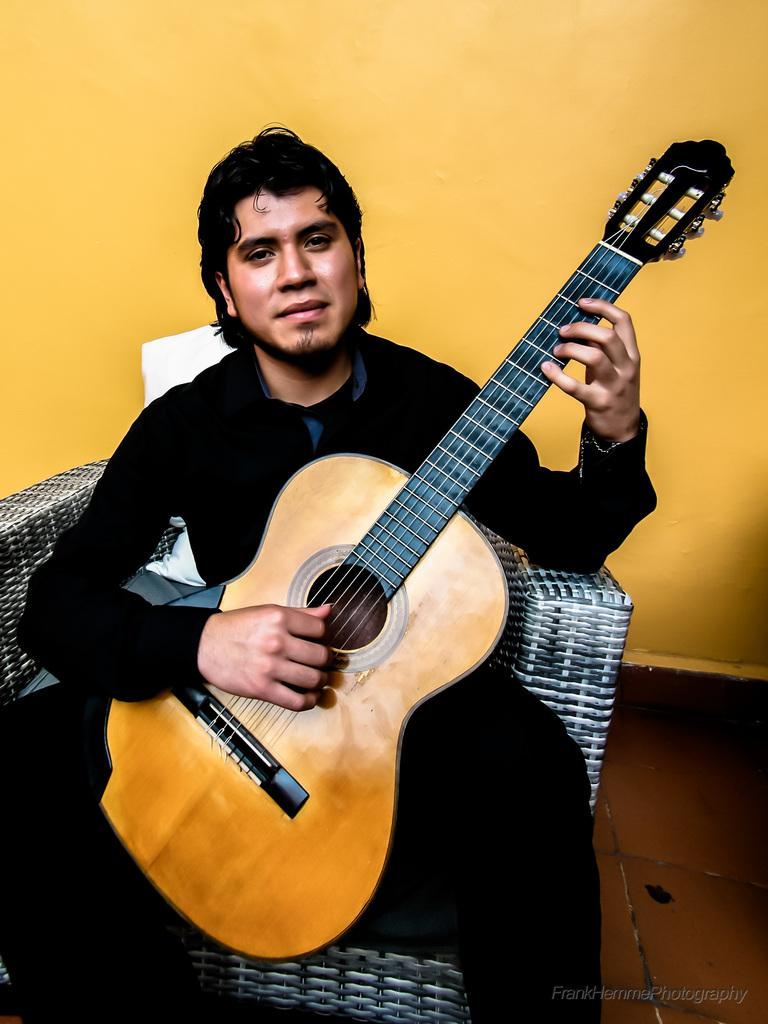What is the main subject of the image? The main subject of the image is a man. What is the man wearing? The man is wearing a black dress. What is the man doing in the image? The man is sitting on a chair, holding a guitar, and playing it. How is the man feeling in the image? The man is smiling, which suggests he is happy or enjoying himself. What color can be seen on the wall in the background? The wall in the background has a yellow color. Can you tell me how many cushions are on the floor in the image? There is no mention of cushions in the image, so it is not possible to answer that question. 